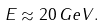<formula> <loc_0><loc_0><loc_500><loc_500>E \approx 2 0 \, G e V .</formula> 